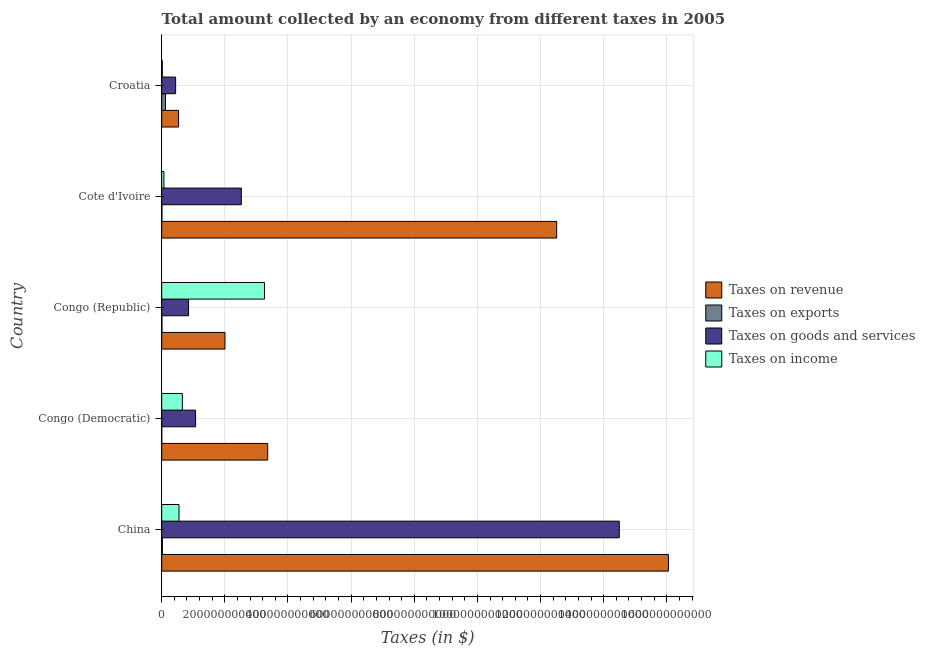How many different coloured bars are there?
Provide a short and direct response. 4. Are the number of bars on each tick of the Y-axis equal?
Your answer should be compact. Yes. How many bars are there on the 1st tick from the top?
Give a very brief answer. 4. What is the label of the 1st group of bars from the top?
Provide a short and direct response. Croatia. In how many cases, is the number of bars for a given country not equal to the number of legend labels?
Give a very brief answer. 0. What is the amount collected as tax on exports in Cote d'Ivoire?
Offer a very short reply. 6.98e+08. Across all countries, what is the maximum amount collected as tax on exports?
Give a very brief answer. 1.20e+1. Across all countries, what is the minimum amount collected as tax on goods?
Your answer should be very brief. 4.41e+1. In which country was the amount collected as tax on exports maximum?
Make the answer very short. Croatia. In which country was the amount collected as tax on revenue minimum?
Your answer should be compact. Croatia. What is the total amount collected as tax on goods in the graph?
Ensure brevity in your answer.  1.94e+12. What is the difference between the amount collected as tax on income in Congo (Democratic) and that in Cote d'Ivoire?
Your answer should be compact. 5.84e+1. What is the difference between the amount collected as tax on goods in Croatia and the amount collected as tax on income in Congo (Democratic)?
Make the answer very short. -2.13e+1. What is the average amount collected as tax on income per country?
Offer a terse response. 9.10e+1. What is the difference between the amount collected as tax on revenue and amount collected as tax on exports in Croatia?
Ensure brevity in your answer.  4.14e+1. In how many countries, is the amount collected as tax on revenue greater than 480000000000 $?
Provide a short and direct response. 2. What is the ratio of the amount collected as tax on goods in Cote d'Ivoire to that in Croatia?
Provide a succinct answer. 5.72. What is the difference between the highest and the second highest amount collected as tax on revenue?
Keep it short and to the point. 3.54e+11. What is the difference between the highest and the lowest amount collected as tax on exports?
Make the answer very short. 1.20e+1. Is the sum of the amount collected as tax on goods in China and Cote d'Ivoire greater than the maximum amount collected as tax on exports across all countries?
Your answer should be compact. Yes. What does the 3rd bar from the top in Congo (Democratic) represents?
Your answer should be compact. Taxes on exports. What does the 2nd bar from the bottom in Congo (Republic) represents?
Your answer should be very brief. Taxes on exports. Are all the bars in the graph horizontal?
Ensure brevity in your answer.  Yes. How many countries are there in the graph?
Your answer should be compact. 5. What is the difference between two consecutive major ticks on the X-axis?
Ensure brevity in your answer.  2.00e+11. Are the values on the major ticks of X-axis written in scientific E-notation?
Provide a succinct answer. No. Does the graph contain any zero values?
Provide a succinct answer. No. Does the graph contain grids?
Your answer should be very brief. Yes. Where does the legend appear in the graph?
Your answer should be compact. Center right. How are the legend labels stacked?
Your answer should be very brief. Vertical. What is the title of the graph?
Provide a short and direct response. Total amount collected by an economy from different taxes in 2005. Does "Italy" appear as one of the legend labels in the graph?
Your response must be concise. No. What is the label or title of the X-axis?
Your answer should be very brief. Taxes (in $). What is the Taxes (in $) of Taxes on revenue in China?
Offer a very short reply. 1.61e+12. What is the Taxes (in $) in Taxes on exports in China?
Your response must be concise. 2.08e+09. What is the Taxes (in $) in Taxes on goods and services in China?
Provide a short and direct response. 1.45e+12. What is the Taxes (in $) in Taxes on income in China?
Your response must be concise. 5.48e+1. What is the Taxes (in $) in Taxes on revenue in Congo (Democratic)?
Offer a terse response. 3.36e+11. What is the Taxes (in $) of Taxes on exports in Congo (Democratic)?
Provide a short and direct response. 8.52e+06. What is the Taxes (in $) of Taxes on goods and services in Congo (Democratic)?
Your answer should be compact. 1.07e+11. What is the Taxes (in $) in Taxes on income in Congo (Democratic)?
Offer a very short reply. 6.54e+1. What is the Taxes (in $) in Taxes on revenue in Congo (Republic)?
Give a very brief answer. 2.00e+11. What is the Taxes (in $) in Taxes on exports in Congo (Republic)?
Keep it short and to the point. 7.10e+08. What is the Taxes (in $) of Taxes on goods and services in Congo (Republic)?
Ensure brevity in your answer.  8.51e+1. What is the Taxes (in $) in Taxes on income in Congo (Republic)?
Provide a short and direct response. 3.26e+11. What is the Taxes (in $) of Taxes on revenue in Cote d'Ivoire?
Offer a terse response. 1.25e+12. What is the Taxes (in $) of Taxes on exports in Cote d'Ivoire?
Provide a short and direct response. 6.98e+08. What is the Taxes (in $) of Taxes on goods and services in Cote d'Ivoire?
Ensure brevity in your answer.  2.52e+11. What is the Taxes (in $) in Taxes on income in Cote d'Ivoire?
Your answer should be very brief. 7.06e+09. What is the Taxes (in $) in Taxes on revenue in Croatia?
Offer a terse response. 5.34e+1. What is the Taxes (in $) of Taxes on exports in Croatia?
Ensure brevity in your answer.  1.20e+1. What is the Taxes (in $) of Taxes on goods and services in Croatia?
Offer a very short reply. 4.41e+1. What is the Taxes (in $) in Taxes on income in Croatia?
Make the answer very short. 1.96e+09. Across all countries, what is the maximum Taxes (in $) of Taxes on revenue?
Give a very brief answer. 1.61e+12. Across all countries, what is the maximum Taxes (in $) of Taxes on exports?
Provide a succinct answer. 1.20e+1. Across all countries, what is the maximum Taxes (in $) of Taxes on goods and services?
Ensure brevity in your answer.  1.45e+12. Across all countries, what is the maximum Taxes (in $) of Taxes on income?
Make the answer very short. 3.26e+11. Across all countries, what is the minimum Taxes (in $) in Taxes on revenue?
Offer a terse response. 5.34e+1. Across all countries, what is the minimum Taxes (in $) in Taxes on exports?
Offer a very short reply. 8.52e+06. Across all countries, what is the minimum Taxes (in $) in Taxes on goods and services?
Make the answer very short. 4.41e+1. Across all countries, what is the minimum Taxes (in $) in Taxes on income?
Your response must be concise. 1.96e+09. What is the total Taxes (in $) in Taxes on revenue in the graph?
Your answer should be very brief. 3.45e+12. What is the total Taxes (in $) in Taxes on exports in the graph?
Provide a short and direct response. 1.55e+1. What is the total Taxes (in $) in Taxes on goods and services in the graph?
Keep it short and to the point. 1.94e+12. What is the total Taxes (in $) in Taxes on income in the graph?
Keep it short and to the point. 4.55e+11. What is the difference between the Taxes (in $) in Taxes on revenue in China and that in Congo (Democratic)?
Keep it short and to the point. 1.27e+12. What is the difference between the Taxes (in $) of Taxes on exports in China and that in Congo (Democratic)?
Give a very brief answer. 2.08e+09. What is the difference between the Taxes (in $) of Taxes on goods and services in China and that in Congo (Democratic)?
Provide a short and direct response. 1.34e+12. What is the difference between the Taxes (in $) in Taxes on income in China and that in Congo (Democratic)?
Give a very brief answer. -1.07e+1. What is the difference between the Taxes (in $) in Taxes on revenue in China and that in Congo (Republic)?
Ensure brevity in your answer.  1.40e+12. What is the difference between the Taxes (in $) in Taxes on exports in China and that in Congo (Republic)?
Provide a short and direct response. 1.38e+09. What is the difference between the Taxes (in $) in Taxes on goods and services in China and that in Congo (Republic)?
Your answer should be very brief. 1.36e+12. What is the difference between the Taxes (in $) of Taxes on income in China and that in Congo (Republic)?
Your answer should be compact. -2.71e+11. What is the difference between the Taxes (in $) of Taxes on revenue in China and that in Cote d'Ivoire?
Keep it short and to the point. 3.54e+11. What is the difference between the Taxes (in $) of Taxes on exports in China and that in Cote d'Ivoire?
Ensure brevity in your answer.  1.39e+09. What is the difference between the Taxes (in $) of Taxes on goods and services in China and that in Cote d'Ivoire?
Make the answer very short. 1.20e+12. What is the difference between the Taxes (in $) in Taxes on income in China and that in Cote d'Ivoire?
Keep it short and to the point. 4.77e+1. What is the difference between the Taxes (in $) of Taxes on revenue in China and that in Croatia?
Offer a very short reply. 1.55e+12. What is the difference between the Taxes (in $) of Taxes on exports in China and that in Croatia?
Give a very brief answer. -9.93e+09. What is the difference between the Taxes (in $) in Taxes on goods and services in China and that in Croatia?
Offer a very short reply. 1.41e+12. What is the difference between the Taxes (in $) of Taxes on income in China and that in Croatia?
Provide a succinct answer. 5.28e+1. What is the difference between the Taxes (in $) in Taxes on revenue in Congo (Democratic) and that in Congo (Republic)?
Keep it short and to the point. 1.35e+11. What is the difference between the Taxes (in $) of Taxes on exports in Congo (Democratic) and that in Congo (Republic)?
Keep it short and to the point. -7.01e+08. What is the difference between the Taxes (in $) in Taxes on goods and services in Congo (Democratic) and that in Congo (Republic)?
Offer a very short reply. 2.23e+1. What is the difference between the Taxes (in $) of Taxes on income in Congo (Democratic) and that in Congo (Republic)?
Your response must be concise. -2.60e+11. What is the difference between the Taxes (in $) in Taxes on revenue in Congo (Democratic) and that in Cote d'Ivoire?
Ensure brevity in your answer.  -9.15e+11. What is the difference between the Taxes (in $) of Taxes on exports in Congo (Democratic) and that in Cote d'Ivoire?
Offer a terse response. -6.89e+08. What is the difference between the Taxes (in $) of Taxes on goods and services in Congo (Democratic) and that in Cote d'Ivoire?
Keep it short and to the point. -1.45e+11. What is the difference between the Taxes (in $) in Taxes on income in Congo (Democratic) and that in Cote d'Ivoire?
Your answer should be compact. 5.84e+1. What is the difference between the Taxes (in $) in Taxes on revenue in Congo (Democratic) and that in Croatia?
Make the answer very short. 2.82e+11. What is the difference between the Taxes (in $) in Taxes on exports in Congo (Democratic) and that in Croatia?
Your answer should be very brief. -1.20e+1. What is the difference between the Taxes (in $) in Taxes on goods and services in Congo (Democratic) and that in Croatia?
Make the answer very short. 6.32e+1. What is the difference between the Taxes (in $) in Taxes on income in Congo (Democratic) and that in Croatia?
Keep it short and to the point. 6.35e+1. What is the difference between the Taxes (in $) in Taxes on revenue in Congo (Republic) and that in Cote d'Ivoire?
Keep it short and to the point. -1.05e+12. What is the difference between the Taxes (in $) of Taxes on goods and services in Congo (Republic) and that in Cote d'Ivoire?
Offer a terse response. -1.67e+11. What is the difference between the Taxes (in $) in Taxes on income in Congo (Republic) and that in Cote d'Ivoire?
Your answer should be very brief. 3.19e+11. What is the difference between the Taxes (in $) of Taxes on revenue in Congo (Republic) and that in Croatia?
Your answer should be very brief. 1.47e+11. What is the difference between the Taxes (in $) of Taxes on exports in Congo (Republic) and that in Croatia?
Your response must be concise. -1.13e+1. What is the difference between the Taxes (in $) of Taxes on goods and services in Congo (Republic) and that in Croatia?
Provide a succinct answer. 4.10e+1. What is the difference between the Taxes (in $) in Taxes on income in Congo (Republic) and that in Croatia?
Provide a succinct answer. 3.24e+11. What is the difference between the Taxes (in $) in Taxes on revenue in Cote d'Ivoire and that in Croatia?
Keep it short and to the point. 1.20e+12. What is the difference between the Taxes (in $) of Taxes on exports in Cote d'Ivoire and that in Croatia?
Your response must be concise. -1.13e+1. What is the difference between the Taxes (in $) of Taxes on goods and services in Cote d'Ivoire and that in Croatia?
Offer a very short reply. 2.08e+11. What is the difference between the Taxes (in $) in Taxes on income in Cote d'Ivoire and that in Croatia?
Your response must be concise. 5.10e+09. What is the difference between the Taxes (in $) in Taxes on revenue in China and the Taxes (in $) in Taxes on exports in Congo (Democratic)?
Your answer should be compact. 1.61e+12. What is the difference between the Taxes (in $) in Taxes on revenue in China and the Taxes (in $) in Taxes on goods and services in Congo (Democratic)?
Make the answer very short. 1.50e+12. What is the difference between the Taxes (in $) of Taxes on revenue in China and the Taxes (in $) of Taxes on income in Congo (Democratic)?
Make the answer very short. 1.54e+12. What is the difference between the Taxes (in $) of Taxes on exports in China and the Taxes (in $) of Taxes on goods and services in Congo (Democratic)?
Your answer should be very brief. -1.05e+11. What is the difference between the Taxes (in $) of Taxes on exports in China and the Taxes (in $) of Taxes on income in Congo (Democratic)?
Provide a short and direct response. -6.33e+1. What is the difference between the Taxes (in $) in Taxes on goods and services in China and the Taxes (in $) in Taxes on income in Congo (Democratic)?
Ensure brevity in your answer.  1.38e+12. What is the difference between the Taxes (in $) of Taxes on revenue in China and the Taxes (in $) of Taxes on exports in Congo (Republic)?
Make the answer very short. 1.60e+12. What is the difference between the Taxes (in $) in Taxes on revenue in China and the Taxes (in $) in Taxes on goods and services in Congo (Republic)?
Make the answer very short. 1.52e+12. What is the difference between the Taxes (in $) in Taxes on revenue in China and the Taxes (in $) in Taxes on income in Congo (Republic)?
Your response must be concise. 1.28e+12. What is the difference between the Taxes (in $) of Taxes on exports in China and the Taxes (in $) of Taxes on goods and services in Congo (Republic)?
Offer a very short reply. -8.30e+1. What is the difference between the Taxes (in $) in Taxes on exports in China and the Taxes (in $) in Taxes on income in Congo (Republic)?
Keep it short and to the point. -3.24e+11. What is the difference between the Taxes (in $) of Taxes on goods and services in China and the Taxes (in $) of Taxes on income in Congo (Republic)?
Provide a succinct answer. 1.12e+12. What is the difference between the Taxes (in $) of Taxes on revenue in China and the Taxes (in $) of Taxes on exports in Cote d'Ivoire?
Provide a succinct answer. 1.60e+12. What is the difference between the Taxes (in $) in Taxes on revenue in China and the Taxes (in $) in Taxes on goods and services in Cote d'Ivoire?
Ensure brevity in your answer.  1.35e+12. What is the difference between the Taxes (in $) of Taxes on revenue in China and the Taxes (in $) of Taxes on income in Cote d'Ivoire?
Provide a succinct answer. 1.60e+12. What is the difference between the Taxes (in $) of Taxes on exports in China and the Taxes (in $) of Taxes on goods and services in Cote d'Ivoire?
Your response must be concise. -2.50e+11. What is the difference between the Taxes (in $) of Taxes on exports in China and the Taxes (in $) of Taxes on income in Cote d'Ivoire?
Make the answer very short. -4.97e+09. What is the difference between the Taxes (in $) of Taxes on goods and services in China and the Taxes (in $) of Taxes on income in Cote d'Ivoire?
Provide a succinct answer. 1.44e+12. What is the difference between the Taxes (in $) of Taxes on revenue in China and the Taxes (in $) of Taxes on exports in Croatia?
Offer a very short reply. 1.59e+12. What is the difference between the Taxes (in $) of Taxes on revenue in China and the Taxes (in $) of Taxes on goods and services in Croatia?
Your answer should be very brief. 1.56e+12. What is the difference between the Taxes (in $) of Taxes on revenue in China and the Taxes (in $) of Taxes on income in Croatia?
Give a very brief answer. 1.60e+12. What is the difference between the Taxes (in $) of Taxes on exports in China and the Taxes (in $) of Taxes on goods and services in Croatia?
Your response must be concise. -4.20e+1. What is the difference between the Taxes (in $) of Taxes on exports in China and the Taxes (in $) of Taxes on income in Croatia?
Provide a succinct answer. 1.25e+08. What is the difference between the Taxes (in $) of Taxes on goods and services in China and the Taxes (in $) of Taxes on income in Croatia?
Your answer should be very brief. 1.45e+12. What is the difference between the Taxes (in $) of Taxes on revenue in Congo (Democratic) and the Taxes (in $) of Taxes on exports in Congo (Republic)?
Your answer should be very brief. 3.35e+11. What is the difference between the Taxes (in $) of Taxes on revenue in Congo (Democratic) and the Taxes (in $) of Taxes on goods and services in Congo (Republic)?
Provide a short and direct response. 2.51e+11. What is the difference between the Taxes (in $) of Taxes on revenue in Congo (Democratic) and the Taxes (in $) of Taxes on income in Congo (Republic)?
Keep it short and to the point. 1.01e+1. What is the difference between the Taxes (in $) in Taxes on exports in Congo (Democratic) and the Taxes (in $) in Taxes on goods and services in Congo (Republic)?
Offer a terse response. -8.51e+1. What is the difference between the Taxes (in $) in Taxes on exports in Congo (Democratic) and the Taxes (in $) in Taxes on income in Congo (Republic)?
Provide a short and direct response. -3.26e+11. What is the difference between the Taxes (in $) in Taxes on goods and services in Congo (Democratic) and the Taxes (in $) in Taxes on income in Congo (Republic)?
Keep it short and to the point. -2.18e+11. What is the difference between the Taxes (in $) of Taxes on revenue in Congo (Democratic) and the Taxes (in $) of Taxes on exports in Cote d'Ivoire?
Ensure brevity in your answer.  3.35e+11. What is the difference between the Taxes (in $) of Taxes on revenue in Congo (Democratic) and the Taxes (in $) of Taxes on goods and services in Cote d'Ivoire?
Your answer should be compact. 8.35e+1. What is the difference between the Taxes (in $) in Taxes on revenue in Congo (Democratic) and the Taxes (in $) in Taxes on income in Cote d'Ivoire?
Keep it short and to the point. 3.29e+11. What is the difference between the Taxes (in $) in Taxes on exports in Congo (Democratic) and the Taxes (in $) in Taxes on goods and services in Cote d'Ivoire?
Your response must be concise. -2.52e+11. What is the difference between the Taxes (in $) of Taxes on exports in Congo (Democratic) and the Taxes (in $) of Taxes on income in Cote d'Ivoire?
Offer a terse response. -7.05e+09. What is the difference between the Taxes (in $) in Taxes on goods and services in Congo (Democratic) and the Taxes (in $) in Taxes on income in Cote d'Ivoire?
Ensure brevity in your answer.  1.00e+11. What is the difference between the Taxes (in $) in Taxes on revenue in Congo (Democratic) and the Taxes (in $) in Taxes on exports in Croatia?
Your answer should be very brief. 3.24e+11. What is the difference between the Taxes (in $) in Taxes on revenue in Congo (Democratic) and the Taxes (in $) in Taxes on goods and services in Croatia?
Your answer should be compact. 2.92e+11. What is the difference between the Taxes (in $) in Taxes on revenue in Congo (Democratic) and the Taxes (in $) in Taxes on income in Croatia?
Offer a very short reply. 3.34e+11. What is the difference between the Taxes (in $) of Taxes on exports in Congo (Democratic) and the Taxes (in $) of Taxes on goods and services in Croatia?
Give a very brief answer. -4.41e+1. What is the difference between the Taxes (in $) in Taxes on exports in Congo (Democratic) and the Taxes (in $) in Taxes on income in Croatia?
Ensure brevity in your answer.  -1.95e+09. What is the difference between the Taxes (in $) of Taxes on goods and services in Congo (Democratic) and the Taxes (in $) of Taxes on income in Croatia?
Your answer should be compact. 1.05e+11. What is the difference between the Taxes (in $) in Taxes on revenue in Congo (Republic) and the Taxes (in $) in Taxes on exports in Cote d'Ivoire?
Your answer should be very brief. 2.00e+11. What is the difference between the Taxes (in $) of Taxes on revenue in Congo (Republic) and the Taxes (in $) of Taxes on goods and services in Cote d'Ivoire?
Keep it short and to the point. -5.18e+1. What is the difference between the Taxes (in $) of Taxes on revenue in Congo (Republic) and the Taxes (in $) of Taxes on income in Cote d'Ivoire?
Your answer should be compact. 1.93e+11. What is the difference between the Taxes (in $) in Taxes on exports in Congo (Republic) and the Taxes (in $) in Taxes on goods and services in Cote d'Ivoire?
Offer a very short reply. -2.51e+11. What is the difference between the Taxes (in $) of Taxes on exports in Congo (Republic) and the Taxes (in $) of Taxes on income in Cote d'Ivoire?
Keep it short and to the point. -6.35e+09. What is the difference between the Taxes (in $) of Taxes on goods and services in Congo (Republic) and the Taxes (in $) of Taxes on income in Cote d'Ivoire?
Your answer should be compact. 7.80e+1. What is the difference between the Taxes (in $) of Taxes on revenue in Congo (Republic) and the Taxes (in $) of Taxes on exports in Croatia?
Offer a very short reply. 1.88e+11. What is the difference between the Taxes (in $) of Taxes on revenue in Congo (Republic) and the Taxes (in $) of Taxes on goods and services in Croatia?
Your response must be concise. 1.56e+11. What is the difference between the Taxes (in $) of Taxes on revenue in Congo (Republic) and the Taxes (in $) of Taxes on income in Croatia?
Give a very brief answer. 1.98e+11. What is the difference between the Taxes (in $) of Taxes on exports in Congo (Republic) and the Taxes (in $) of Taxes on goods and services in Croatia?
Give a very brief answer. -4.34e+1. What is the difference between the Taxes (in $) in Taxes on exports in Congo (Republic) and the Taxes (in $) in Taxes on income in Croatia?
Your answer should be very brief. -1.25e+09. What is the difference between the Taxes (in $) in Taxes on goods and services in Congo (Republic) and the Taxes (in $) in Taxes on income in Croatia?
Give a very brief answer. 8.31e+1. What is the difference between the Taxes (in $) of Taxes on revenue in Cote d'Ivoire and the Taxes (in $) of Taxes on exports in Croatia?
Make the answer very short. 1.24e+12. What is the difference between the Taxes (in $) of Taxes on revenue in Cote d'Ivoire and the Taxes (in $) of Taxes on goods and services in Croatia?
Your response must be concise. 1.21e+12. What is the difference between the Taxes (in $) in Taxes on revenue in Cote d'Ivoire and the Taxes (in $) in Taxes on income in Croatia?
Keep it short and to the point. 1.25e+12. What is the difference between the Taxes (in $) of Taxes on exports in Cote d'Ivoire and the Taxes (in $) of Taxes on goods and services in Croatia?
Ensure brevity in your answer.  -4.34e+1. What is the difference between the Taxes (in $) of Taxes on exports in Cote d'Ivoire and the Taxes (in $) of Taxes on income in Croatia?
Your response must be concise. -1.26e+09. What is the difference between the Taxes (in $) of Taxes on goods and services in Cote d'Ivoire and the Taxes (in $) of Taxes on income in Croatia?
Your response must be concise. 2.50e+11. What is the average Taxes (in $) in Taxes on revenue per country?
Offer a terse response. 6.89e+11. What is the average Taxes (in $) of Taxes on exports per country?
Provide a succinct answer. 3.10e+09. What is the average Taxes (in $) in Taxes on goods and services per country?
Provide a succinct answer. 3.88e+11. What is the average Taxes (in $) of Taxes on income per country?
Ensure brevity in your answer.  9.10e+1. What is the difference between the Taxes (in $) in Taxes on revenue and Taxes (in $) in Taxes on exports in China?
Provide a short and direct response. 1.60e+12. What is the difference between the Taxes (in $) of Taxes on revenue and Taxes (in $) of Taxes on goods and services in China?
Your answer should be very brief. 1.56e+11. What is the difference between the Taxes (in $) of Taxes on revenue and Taxes (in $) of Taxes on income in China?
Your response must be concise. 1.55e+12. What is the difference between the Taxes (in $) of Taxes on exports and Taxes (in $) of Taxes on goods and services in China?
Ensure brevity in your answer.  -1.45e+12. What is the difference between the Taxes (in $) of Taxes on exports and Taxes (in $) of Taxes on income in China?
Offer a very short reply. -5.27e+1. What is the difference between the Taxes (in $) of Taxes on goods and services and Taxes (in $) of Taxes on income in China?
Your response must be concise. 1.39e+12. What is the difference between the Taxes (in $) in Taxes on revenue and Taxes (in $) in Taxes on exports in Congo (Democratic)?
Keep it short and to the point. 3.36e+11. What is the difference between the Taxes (in $) in Taxes on revenue and Taxes (in $) in Taxes on goods and services in Congo (Democratic)?
Provide a succinct answer. 2.28e+11. What is the difference between the Taxes (in $) of Taxes on revenue and Taxes (in $) of Taxes on income in Congo (Democratic)?
Provide a succinct answer. 2.70e+11. What is the difference between the Taxes (in $) of Taxes on exports and Taxes (in $) of Taxes on goods and services in Congo (Democratic)?
Offer a terse response. -1.07e+11. What is the difference between the Taxes (in $) of Taxes on exports and Taxes (in $) of Taxes on income in Congo (Democratic)?
Your answer should be very brief. -6.54e+1. What is the difference between the Taxes (in $) of Taxes on goods and services and Taxes (in $) of Taxes on income in Congo (Democratic)?
Offer a very short reply. 4.19e+1. What is the difference between the Taxes (in $) of Taxes on revenue and Taxes (in $) of Taxes on exports in Congo (Republic)?
Make the answer very short. 2.00e+11. What is the difference between the Taxes (in $) in Taxes on revenue and Taxes (in $) in Taxes on goods and services in Congo (Republic)?
Provide a short and direct response. 1.15e+11. What is the difference between the Taxes (in $) in Taxes on revenue and Taxes (in $) in Taxes on income in Congo (Republic)?
Provide a short and direct response. -1.25e+11. What is the difference between the Taxes (in $) of Taxes on exports and Taxes (in $) of Taxes on goods and services in Congo (Republic)?
Keep it short and to the point. -8.44e+1. What is the difference between the Taxes (in $) in Taxes on exports and Taxes (in $) in Taxes on income in Congo (Republic)?
Your answer should be very brief. -3.25e+11. What is the difference between the Taxes (in $) in Taxes on goods and services and Taxes (in $) in Taxes on income in Congo (Republic)?
Offer a very short reply. -2.41e+11. What is the difference between the Taxes (in $) in Taxes on revenue and Taxes (in $) in Taxes on exports in Cote d'Ivoire?
Provide a short and direct response. 1.25e+12. What is the difference between the Taxes (in $) of Taxes on revenue and Taxes (in $) of Taxes on goods and services in Cote d'Ivoire?
Provide a succinct answer. 9.99e+11. What is the difference between the Taxes (in $) in Taxes on revenue and Taxes (in $) in Taxes on income in Cote d'Ivoire?
Offer a very short reply. 1.24e+12. What is the difference between the Taxes (in $) of Taxes on exports and Taxes (in $) of Taxes on goods and services in Cote d'Ivoire?
Offer a very short reply. -2.52e+11. What is the difference between the Taxes (in $) in Taxes on exports and Taxes (in $) in Taxes on income in Cote d'Ivoire?
Your answer should be very brief. -6.36e+09. What is the difference between the Taxes (in $) in Taxes on goods and services and Taxes (in $) in Taxes on income in Cote d'Ivoire?
Offer a very short reply. 2.45e+11. What is the difference between the Taxes (in $) of Taxes on revenue and Taxes (in $) of Taxes on exports in Croatia?
Make the answer very short. 4.14e+1. What is the difference between the Taxes (in $) in Taxes on revenue and Taxes (in $) in Taxes on goods and services in Croatia?
Your response must be concise. 9.36e+09. What is the difference between the Taxes (in $) of Taxes on revenue and Taxes (in $) of Taxes on income in Croatia?
Your answer should be compact. 5.15e+1. What is the difference between the Taxes (in $) of Taxes on exports and Taxes (in $) of Taxes on goods and services in Croatia?
Your answer should be very brief. -3.21e+1. What is the difference between the Taxes (in $) in Taxes on exports and Taxes (in $) in Taxes on income in Croatia?
Ensure brevity in your answer.  1.01e+1. What is the difference between the Taxes (in $) of Taxes on goods and services and Taxes (in $) of Taxes on income in Croatia?
Keep it short and to the point. 4.21e+1. What is the ratio of the Taxes (in $) in Taxes on revenue in China to that in Congo (Democratic)?
Your answer should be very brief. 4.78. What is the ratio of the Taxes (in $) of Taxes on exports in China to that in Congo (Democratic)?
Make the answer very short. 244.58. What is the ratio of the Taxes (in $) of Taxes on goods and services in China to that in Congo (Democratic)?
Offer a terse response. 13.51. What is the ratio of the Taxes (in $) of Taxes on income in China to that in Congo (Democratic)?
Your answer should be very brief. 0.84. What is the ratio of the Taxes (in $) in Taxes on revenue in China to that in Congo (Republic)?
Offer a very short reply. 8.01. What is the ratio of the Taxes (in $) of Taxes on exports in China to that in Congo (Republic)?
Offer a terse response. 2.94. What is the ratio of the Taxes (in $) of Taxes on goods and services in China to that in Congo (Republic)?
Your response must be concise. 17.04. What is the ratio of the Taxes (in $) in Taxes on income in China to that in Congo (Republic)?
Give a very brief answer. 0.17. What is the ratio of the Taxes (in $) in Taxes on revenue in China to that in Cote d'Ivoire?
Offer a terse response. 1.28. What is the ratio of the Taxes (in $) in Taxes on exports in China to that in Cote d'Ivoire?
Your response must be concise. 2.99. What is the ratio of the Taxes (in $) in Taxes on goods and services in China to that in Cote d'Ivoire?
Make the answer very short. 5.75. What is the ratio of the Taxes (in $) in Taxes on income in China to that in Cote d'Ivoire?
Ensure brevity in your answer.  7.76. What is the ratio of the Taxes (in $) of Taxes on revenue in China to that in Croatia?
Your response must be concise. 30.03. What is the ratio of the Taxes (in $) in Taxes on exports in China to that in Croatia?
Make the answer very short. 0.17. What is the ratio of the Taxes (in $) in Taxes on goods and services in China to that in Croatia?
Your response must be concise. 32.88. What is the ratio of the Taxes (in $) of Taxes on income in China to that in Croatia?
Make the answer very short. 27.94. What is the ratio of the Taxes (in $) of Taxes on revenue in Congo (Democratic) to that in Congo (Republic)?
Make the answer very short. 1.67. What is the ratio of the Taxes (in $) of Taxes on exports in Congo (Democratic) to that in Congo (Republic)?
Make the answer very short. 0.01. What is the ratio of the Taxes (in $) of Taxes on goods and services in Congo (Democratic) to that in Congo (Republic)?
Ensure brevity in your answer.  1.26. What is the ratio of the Taxes (in $) of Taxes on income in Congo (Democratic) to that in Congo (Republic)?
Offer a terse response. 0.2. What is the ratio of the Taxes (in $) in Taxes on revenue in Congo (Democratic) to that in Cote d'Ivoire?
Your response must be concise. 0.27. What is the ratio of the Taxes (in $) of Taxes on exports in Congo (Democratic) to that in Cote d'Ivoire?
Your response must be concise. 0.01. What is the ratio of the Taxes (in $) in Taxes on goods and services in Congo (Democratic) to that in Cote d'Ivoire?
Provide a succinct answer. 0.43. What is the ratio of the Taxes (in $) of Taxes on income in Congo (Democratic) to that in Cote d'Ivoire?
Your response must be concise. 9.27. What is the ratio of the Taxes (in $) of Taxes on revenue in Congo (Democratic) to that in Croatia?
Provide a short and direct response. 6.28. What is the ratio of the Taxes (in $) of Taxes on exports in Congo (Democratic) to that in Croatia?
Make the answer very short. 0. What is the ratio of the Taxes (in $) of Taxes on goods and services in Congo (Democratic) to that in Croatia?
Keep it short and to the point. 2.43. What is the ratio of the Taxes (in $) of Taxes on income in Congo (Democratic) to that in Croatia?
Your answer should be very brief. 33.37. What is the ratio of the Taxes (in $) of Taxes on revenue in Congo (Republic) to that in Cote d'Ivoire?
Your answer should be very brief. 0.16. What is the ratio of the Taxes (in $) of Taxes on exports in Congo (Republic) to that in Cote d'Ivoire?
Provide a short and direct response. 1.02. What is the ratio of the Taxes (in $) in Taxes on goods and services in Congo (Republic) to that in Cote d'Ivoire?
Provide a short and direct response. 0.34. What is the ratio of the Taxes (in $) in Taxes on income in Congo (Republic) to that in Cote d'Ivoire?
Provide a short and direct response. 46.14. What is the ratio of the Taxes (in $) of Taxes on revenue in Congo (Republic) to that in Croatia?
Keep it short and to the point. 3.75. What is the ratio of the Taxes (in $) in Taxes on exports in Congo (Republic) to that in Croatia?
Your response must be concise. 0.06. What is the ratio of the Taxes (in $) of Taxes on goods and services in Congo (Republic) to that in Croatia?
Ensure brevity in your answer.  1.93. What is the ratio of the Taxes (in $) of Taxes on income in Congo (Republic) to that in Croatia?
Your answer should be compact. 166.1. What is the ratio of the Taxes (in $) in Taxes on revenue in Cote d'Ivoire to that in Croatia?
Provide a short and direct response. 23.41. What is the ratio of the Taxes (in $) in Taxes on exports in Cote d'Ivoire to that in Croatia?
Provide a succinct answer. 0.06. What is the ratio of the Taxes (in $) of Taxes on goods and services in Cote d'Ivoire to that in Croatia?
Give a very brief answer. 5.72. What is the difference between the highest and the second highest Taxes (in $) of Taxes on revenue?
Your response must be concise. 3.54e+11. What is the difference between the highest and the second highest Taxes (in $) in Taxes on exports?
Your answer should be very brief. 9.93e+09. What is the difference between the highest and the second highest Taxes (in $) in Taxes on goods and services?
Keep it short and to the point. 1.20e+12. What is the difference between the highest and the second highest Taxes (in $) in Taxes on income?
Keep it short and to the point. 2.60e+11. What is the difference between the highest and the lowest Taxes (in $) in Taxes on revenue?
Offer a very short reply. 1.55e+12. What is the difference between the highest and the lowest Taxes (in $) in Taxes on exports?
Provide a short and direct response. 1.20e+1. What is the difference between the highest and the lowest Taxes (in $) of Taxes on goods and services?
Your response must be concise. 1.41e+12. What is the difference between the highest and the lowest Taxes (in $) in Taxes on income?
Make the answer very short. 3.24e+11. 